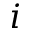Convert formula to latex. <formula><loc_0><loc_0><loc_500><loc_500>i</formula> 